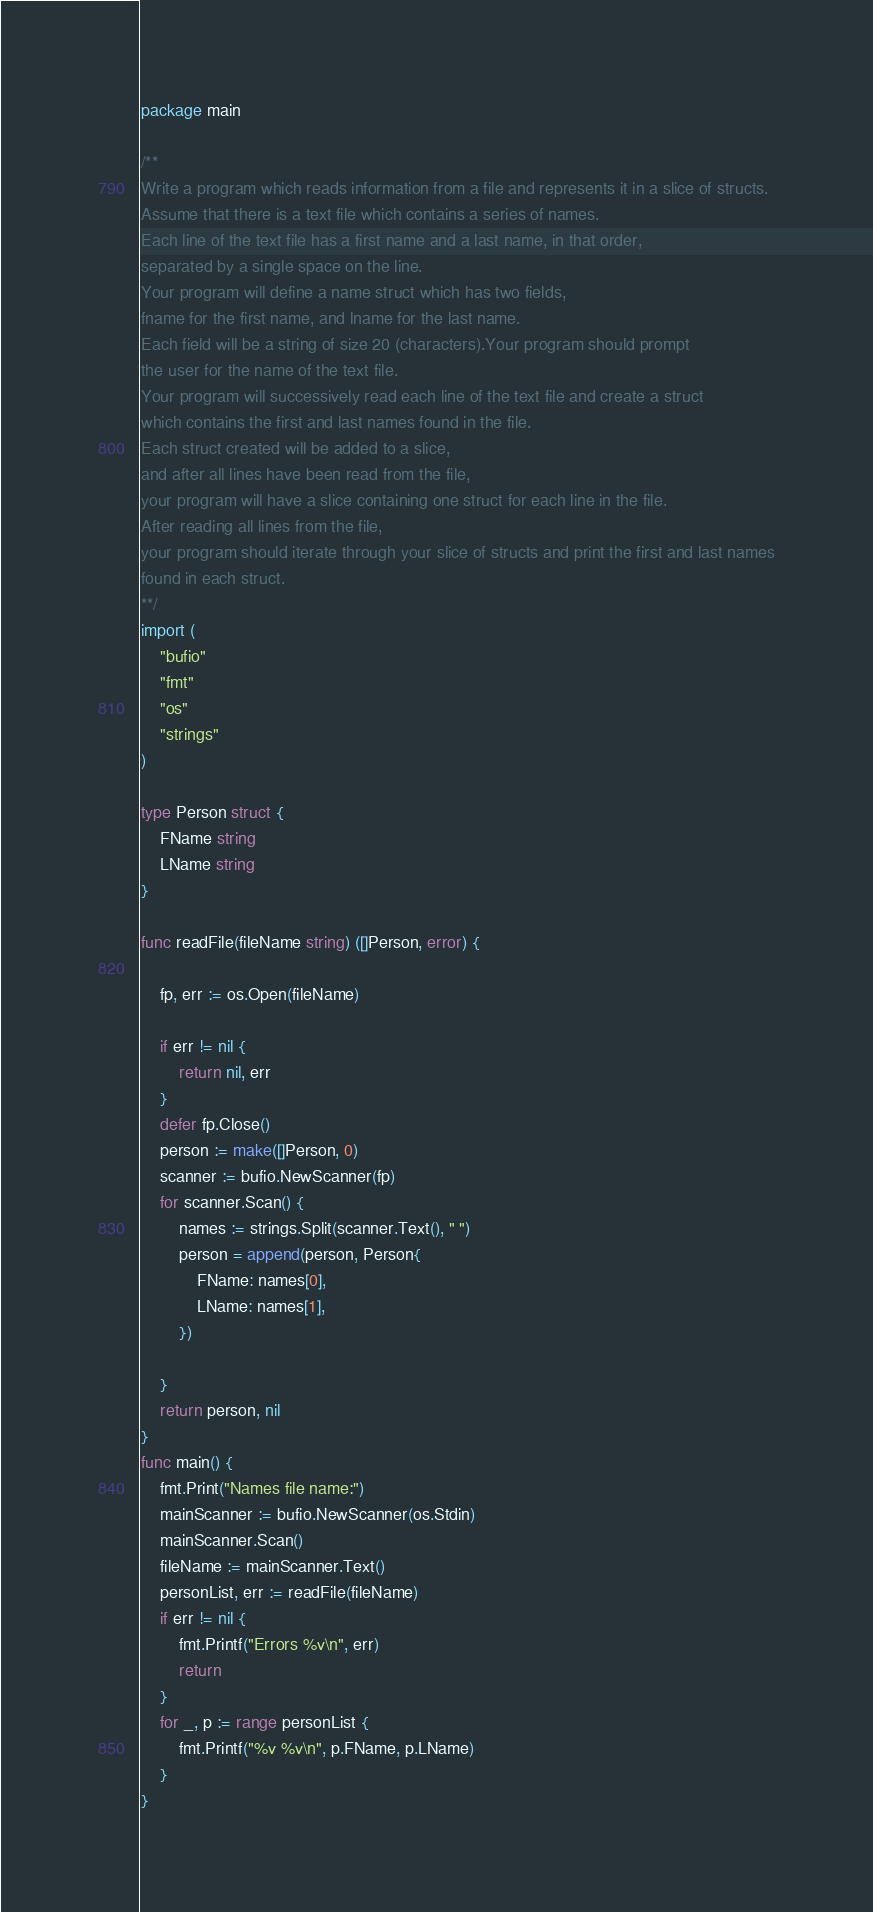<code> <loc_0><loc_0><loc_500><loc_500><_Go_>package main

/**
Write a program which reads information from a file and represents it in a slice of structs.
Assume that there is a text file which contains a series of names.
Each line of the text file has a first name and a last name, in that order,
separated by a single space on the line.
Your program will define a name struct which has two fields,
fname for the first name, and lname for the last name.
Each field will be a string of size 20 (characters).Your program should prompt
the user for the name of the text file.
Your program will successively read each line of the text file and create a struct
which contains the first and last names found in the file.
Each struct created will be added to a slice,
and after all lines have been read from the file,
your program will have a slice containing one struct for each line in the file.
After reading all lines from the file,
your program should iterate through your slice of structs and print the first and last names
found in each struct.
**/
import (
	"bufio"
	"fmt"
	"os"
	"strings"
)

type Person struct {
	FName string
	LName string
}

func readFile(fileName string) ([]Person, error) {

	fp, err := os.Open(fileName)

	if err != nil {
		return nil, err
	}
	defer fp.Close()
	person := make([]Person, 0)
	scanner := bufio.NewScanner(fp)
	for scanner.Scan() {
		names := strings.Split(scanner.Text(), " ")
		person = append(person, Person{
			FName: names[0],
			LName: names[1],
		})

	}
	return person, nil
}
func main() {
	fmt.Print("Names file name:")
	mainScanner := bufio.NewScanner(os.Stdin)
	mainScanner.Scan()
	fileName := mainScanner.Text()
	personList, err := readFile(fileName)
	if err != nil {
		fmt.Printf("Errors %v\n", err)
		return
	}
	for _, p := range personList {
		fmt.Printf("%v %v\n", p.FName, p.LName)
	}
}
</code> 